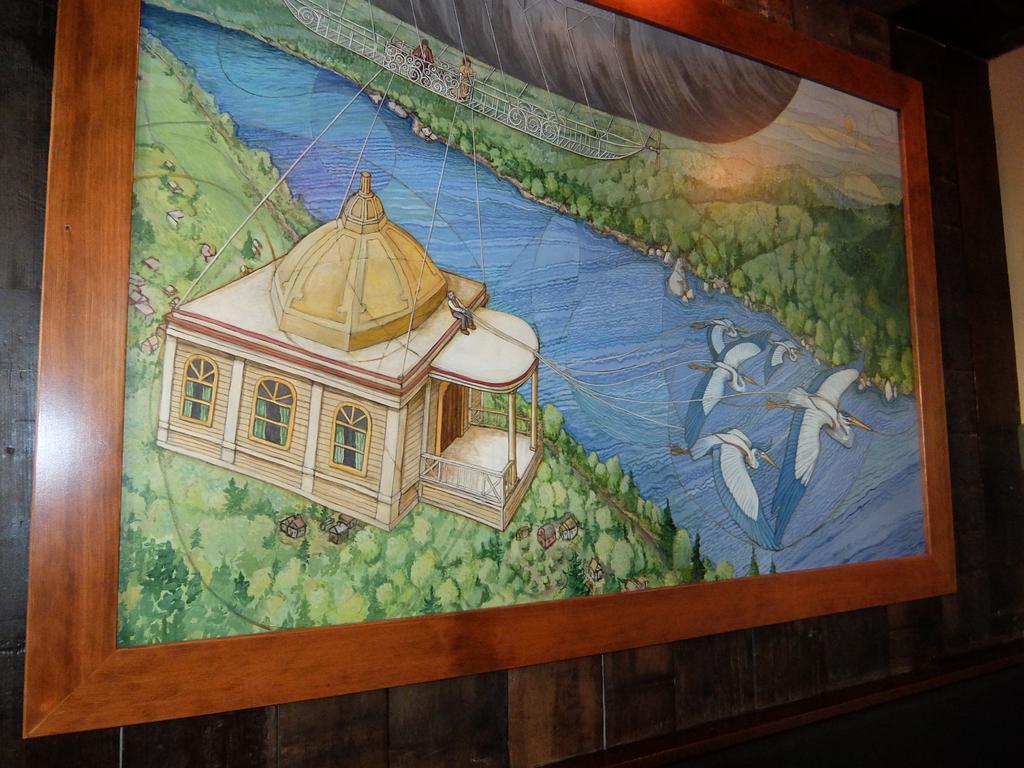Can you describe this image briefly? In this picture I can see a photo frame on the wooden wall. 